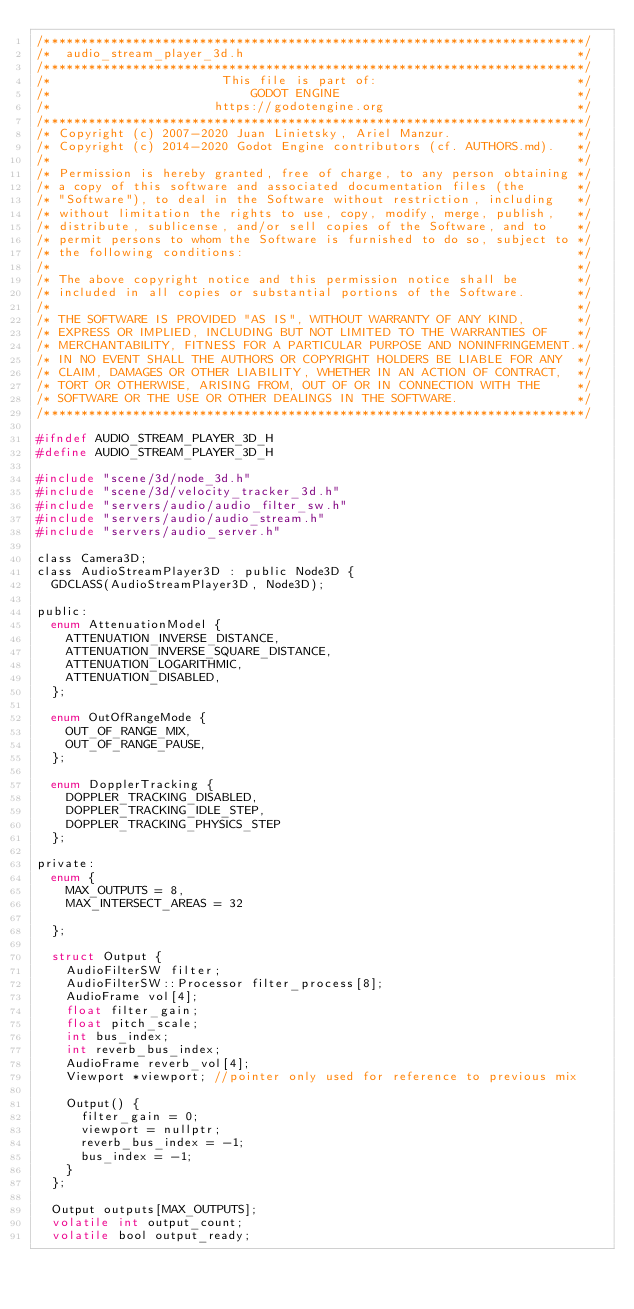Convert code to text. <code><loc_0><loc_0><loc_500><loc_500><_C_>/*************************************************************************/
/*  audio_stream_player_3d.h                                             */
/*************************************************************************/
/*                       This file is part of:                           */
/*                           GODOT ENGINE                                */
/*                      https://godotengine.org                          */
/*************************************************************************/
/* Copyright (c) 2007-2020 Juan Linietsky, Ariel Manzur.                 */
/* Copyright (c) 2014-2020 Godot Engine contributors (cf. AUTHORS.md).   */
/*                                                                       */
/* Permission is hereby granted, free of charge, to any person obtaining */
/* a copy of this software and associated documentation files (the       */
/* "Software"), to deal in the Software without restriction, including   */
/* without limitation the rights to use, copy, modify, merge, publish,   */
/* distribute, sublicense, and/or sell copies of the Software, and to    */
/* permit persons to whom the Software is furnished to do so, subject to */
/* the following conditions:                                             */
/*                                                                       */
/* The above copyright notice and this permission notice shall be        */
/* included in all copies or substantial portions of the Software.       */
/*                                                                       */
/* THE SOFTWARE IS PROVIDED "AS IS", WITHOUT WARRANTY OF ANY KIND,       */
/* EXPRESS OR IMPLIED, INCLUDING BUT NOT LIMITED TO THE WARRANTIES OF    */
/* MERCHANTABILITY, FITNESS FOR A PARTICULAR PURPOSE AND NONINFRINGEMENT.*/
/* IN NO EVENT SHALL THE AUTHORS OR COPYRIGHT HOLDERS BE LIABLE FOR ANY  */
/* CLAIM, DAMAGES OR OTHER LIABILITY, WHETHER IN AN ACTION OF CONTRACT,  */
/* TORT OR OTHERWISE, ARISING FROM, OUT OF OR IN CONNECTION WITH THE     */
/* SOFTWARE OR THE USE OR OTHER DEALINGS IN THE SOFTWARE.                */
/*************************************************************************/

#ifndef AUDIO_STREAM_PLAYER_3D_H
#define AUDIO_STREAM_PLAYER_3D_H

#include "scene/3d/node_3d.h"
#include "scene/3d/velocity_tracker_3d.h"
#include "servers/audio/audio_filter_sw.h"
#include "servers/audio/audio_stream.h"
#include "servers/audio_server.h"

class Camera3D;
class AudioStreamPlayer3D : public Node3D {
	GDCLASS(AudioStreamPlayer3D, Node3D);

public:
	enum AttenuationModel {
		ATTENUATION_INVERSE_DISTANCE,
		ATTENUATION_INVERSE_SQUARE_DISTANCE,
		ATTENUATION_LOGARITHMIC,
		ATTENUATION_DISABLED,
	};

	enum OutOfRangeMode {
		OUT_OF_RANGE_MIX,
		OUT_OF_RANGE_PAUSE,
	};

	enum DopplerTracking {
		DOPPLER_TRACKING_DISABLED,
		DOPPLER_TRACKING_IDLE_STEP,
		DOPPLER_TRACKING_PHYSICS_STEP
	};

private:
	enum {
		MAX_OUTPUTS = 8,
		MAX_INTERSECT_AREAS = 32

	};

	struct Output {
		AudioFilterSW filter;
		AudioFilterSW::Processor filter_process[8];
		AudioFrame vol[4];
		float filter_gain;
		float pitch_scale;
		int bus_index;
		int reverb_bus_index;
		AudioFrame reverb_vol[4];
		Viewport *viewport; //pointer only used for reference to previous mix

		Output() {
			filter_gain = 0;
			viewport = nullptr;
			reverb_bus_index = -1;
			bus_index = -1;
		}
	};

	Output outputs[MAX_OUTPUTS];
	volatile int output_count;
	volatile bool output_ready;
</code> 